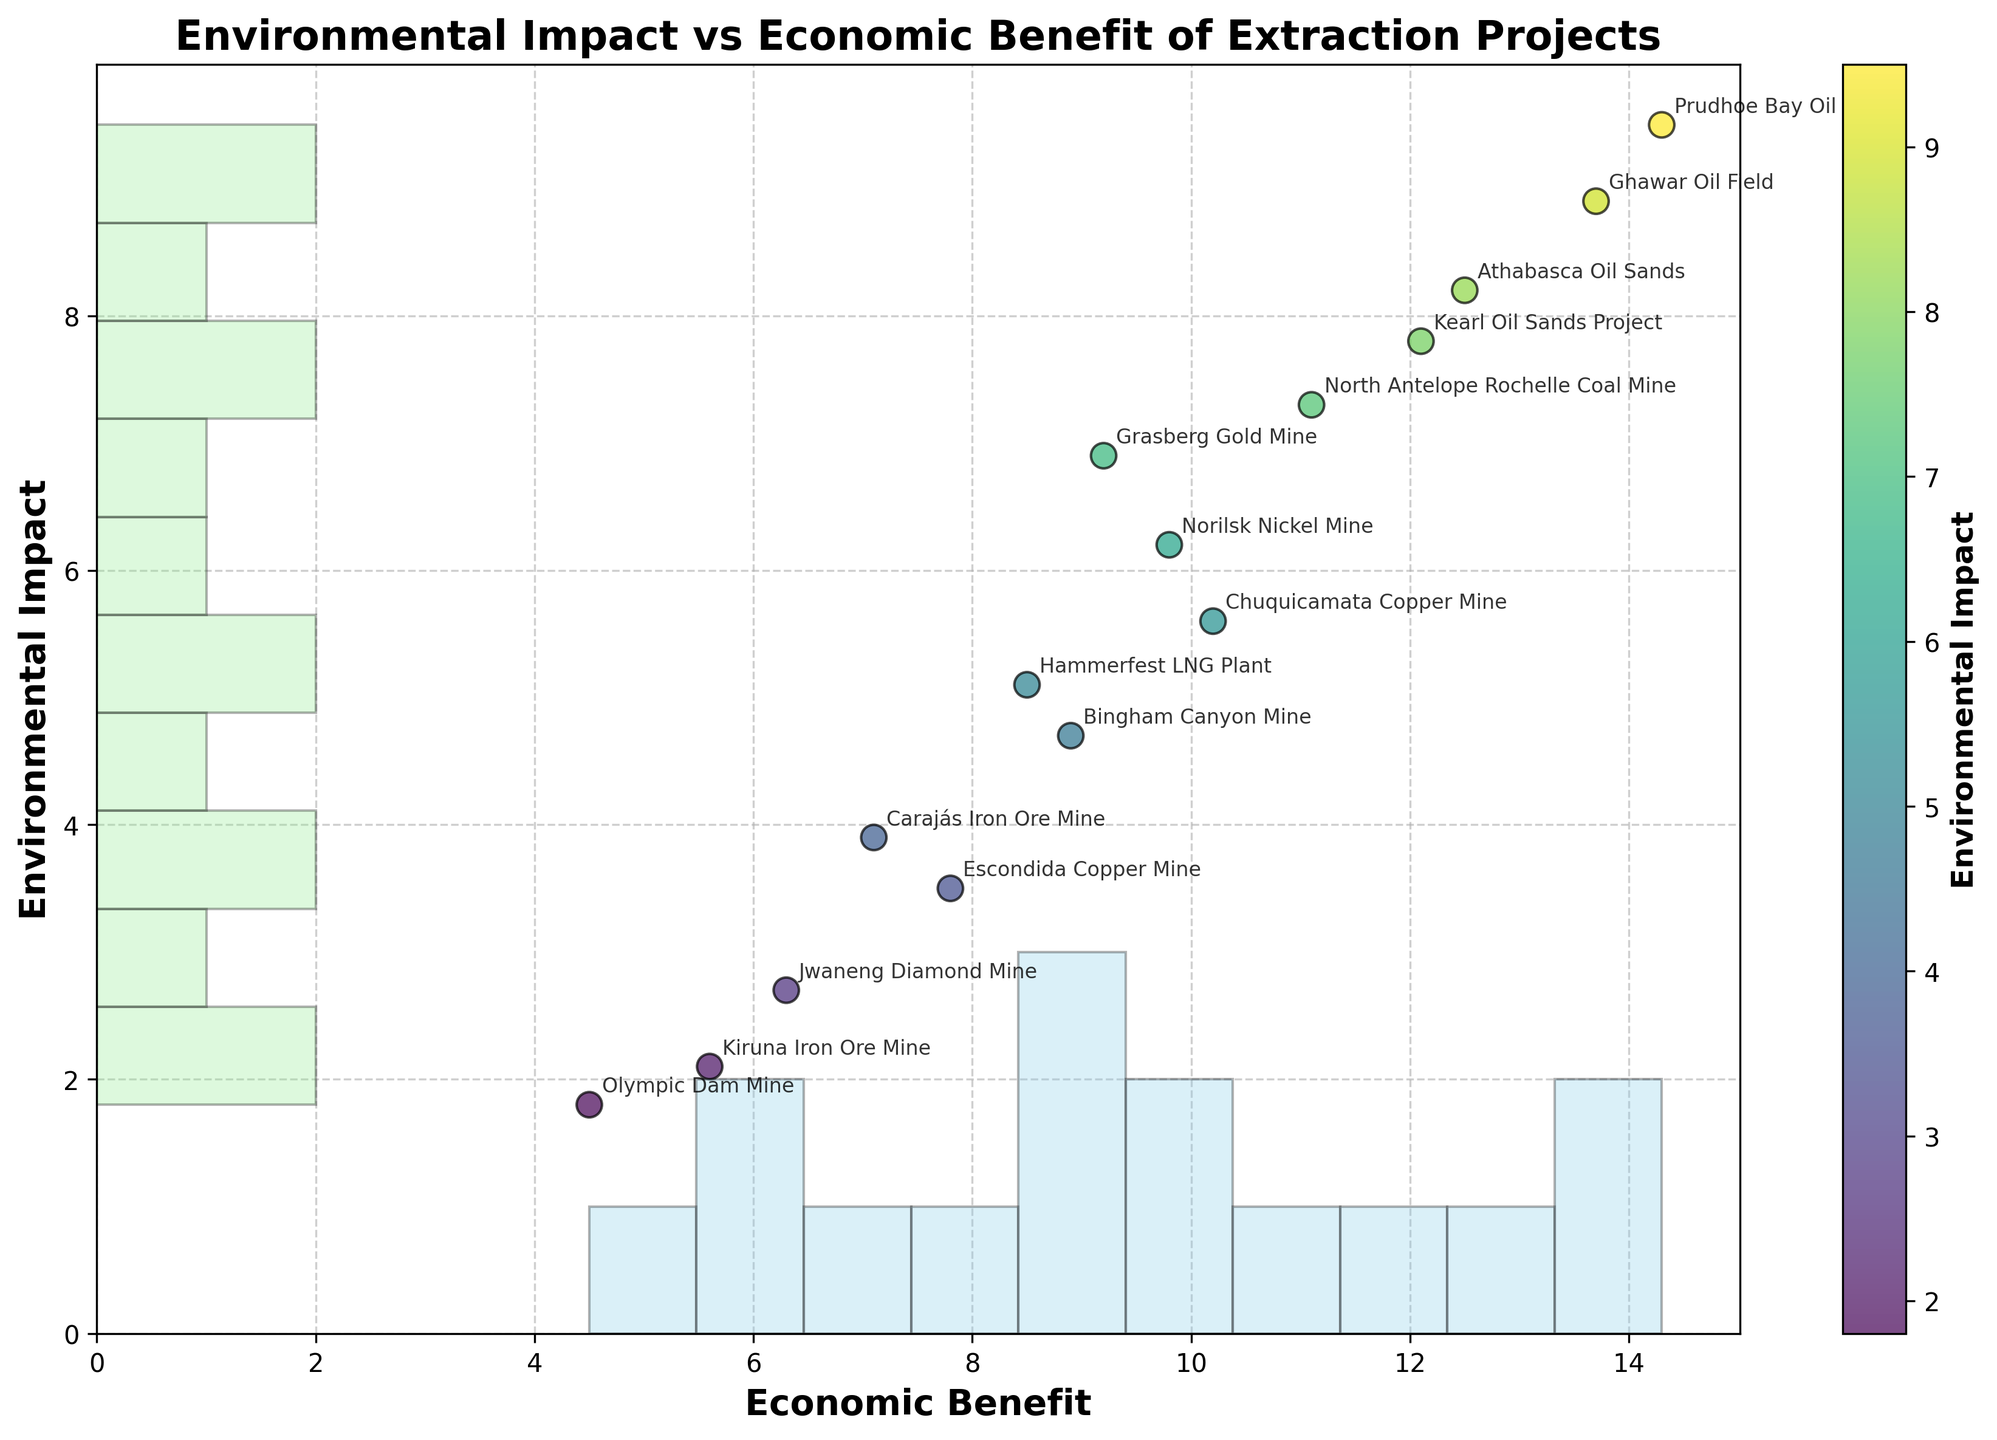How many data points are present in the figure? By counting the number of project names displayed on the scatterplot, we can determine there are 15 data points.
Answer: 15 Which project has the highest economic benefit? From the annotated project names, "Prudhoe Bay Oil Field" has the highest x-coordinate, representing the highest economic benefit of 14.3.
Answer: Prudhoe Bay Oil Field What is the average environmental impact of all projects? Summing up all the "Environmental_Impact" values (8.2 + 3.5 + 6.9 + 2.1 + 9.5 + 4.7 + 7.3 + 5.6 + 1.8 + 8.9 + 3.9 + 6.2 + 2.7 + 5.1 + 7.8) gives 84.2. Dividing by the number of projects (15), the average environmental impact is 84.2 / 15 ≈ 5.61.
Answer: 5.61 Which project has the lowest environmental impact and what is its corresponding economic benefit? "Olympic Dam Mine" has the lowest y-coordinate, representing the lowest environmental impact of 1.8. The corresponding economic benefit is at the x-coordinate 4.5.
Answer: Olympic Dam Mine, 4.5 Compare the environmental impact and economic benefit of the "Grasberg Gold Mine" to the "Carajás Iron Ore Mine." Which has higher values? "Grasberg Gold Mine" has an environmental impact of 6.9 and an economic benefit of 9.2. "Carajás Iron Ore Mine" has an environmental impact of 3.9 and an economic benefit of 7.1. Comparing these, "Grasberg Gold Mine" has higher values for both environmental impact and economic benefit.
Answer: Grasberg Gold Mine What is the ratio of the highest economic benefit to the lowest economic benefit? The highest economic benefit is 14.3 (Prudhoe Bay Oil Field) and the lowest is 4.5 (Olympic Dam Mine). The ratio is 14.3 / 4.5, which simplifies to roughly 3.18.
Answer: 3.18 Identify the project located in the highest density region of the histogram scatterplot and specify the range of its environmental impact. The highest density appears around an environmental impact range of 7.8 - 9.5. "Prudhoe Bay Oil Field" (9.5) is one of the projects located in this high-density region.
Answer: Prudhoe Bay Oil Field, 9.5 Which project has a moderate environmental impact but a high economic benefit, and where is it located on the scatterplot? "North Antelope Rochelle Coal Mine" has a moderate environmental impact of 7.3 and a high economic benefit of 11.1. It is located around the central-right part of the scatterplot.
Answer: North Antelope Rochelle Coal Mine, central-right How are the colors on the scatterplot related to the data points, and what does the color of "Ghawar Oil Field" indicate? The colors on the scatterplot represent the environmental impact, with a colormap ranging from light to dark. "Ghawar Oil Field" has a dark color, indicating a high environmental impact, which is 8.9.
Answer: High environmental impact of 8.9 